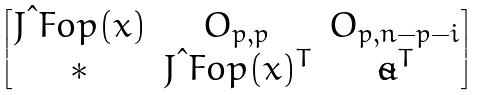Convert formula to latex. <formula><loc_0><loc_0><loc_500><loc_500>\begin{bmatrix} J \i F o p ( x ) & O _ { p , p } & O _ { p , n - p - i } \\ \ast & J \i F o p ( x ) ^ { T } & \tilde { a } ^ { T } \end{bmatrix}</formula> 